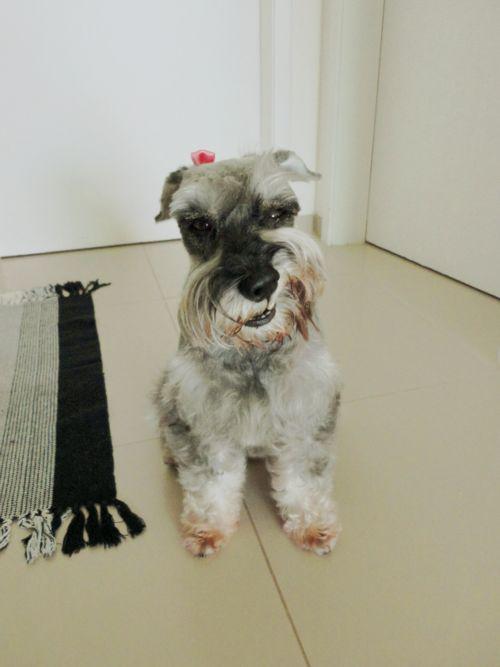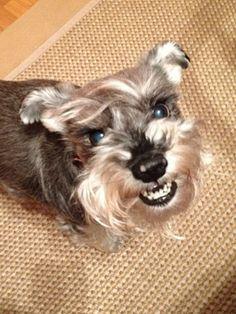The first image is the image on the left, the second image is the image on the right. Given the left and right images, does the statement "A group of dogs is in the green grass in the image on the right." hold true? Answer yes or no. No. The first image is the image on the left, the second image is the image on the right. For the images displayed, is the sentence "Right image shows a group of schnauzers wearing colored collars." factually correct? Answer yes or no. No. 